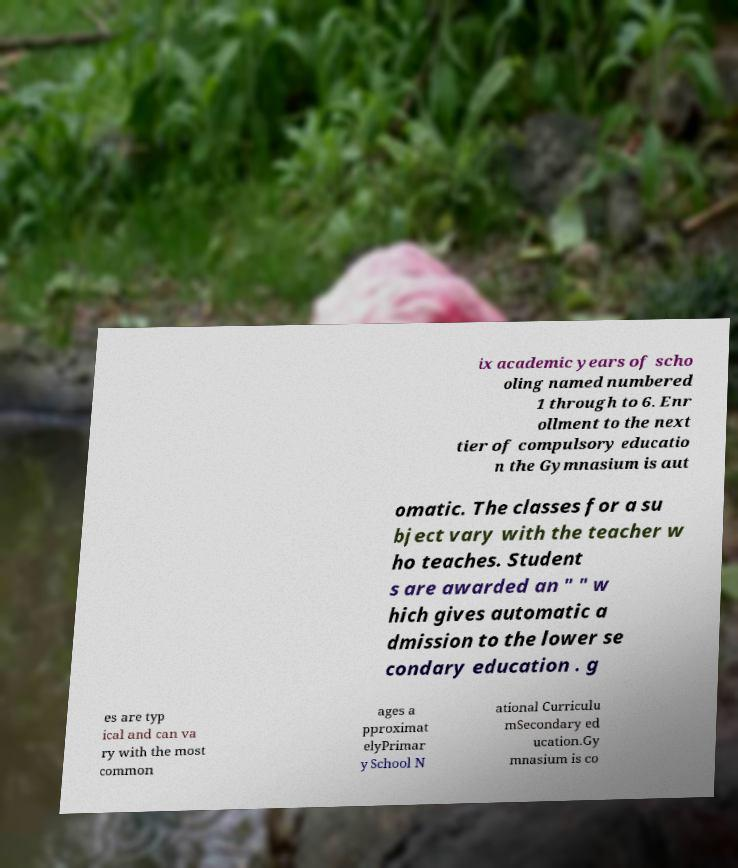Can you accurately transcribe the text from the provided image for me? ix academic years of scho oling named numbered 1 through to 6. Enr ollment to the next tier of compulsory educatio n the Gymnasium is aut omatic. The classes for a su bject vary with the teacher w ho teaches. Student s are awarded an " " w hich gives automatic a dmission to the lower se condary education . g es are typ ical and can va ry with the most common ages a pproximat elyPrimar y School N ational Curriculu mSecondary ed ucation.Gy mnasium is co 